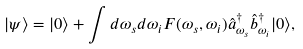<formula> <loc_0><loc_0><loc_500><loc_500>| \psi \rangle = | 0 \rangle + \int d \omega _ { s } d \omega _ { i } F ( \omega _ { s } , \omega _ { i } ) \hat { a } ^ { \dag } _ { \omega _ { s } } \hat { b } ^ { \dag } _ { \omega _ { i } } | 0 \rangle ,</formula> 